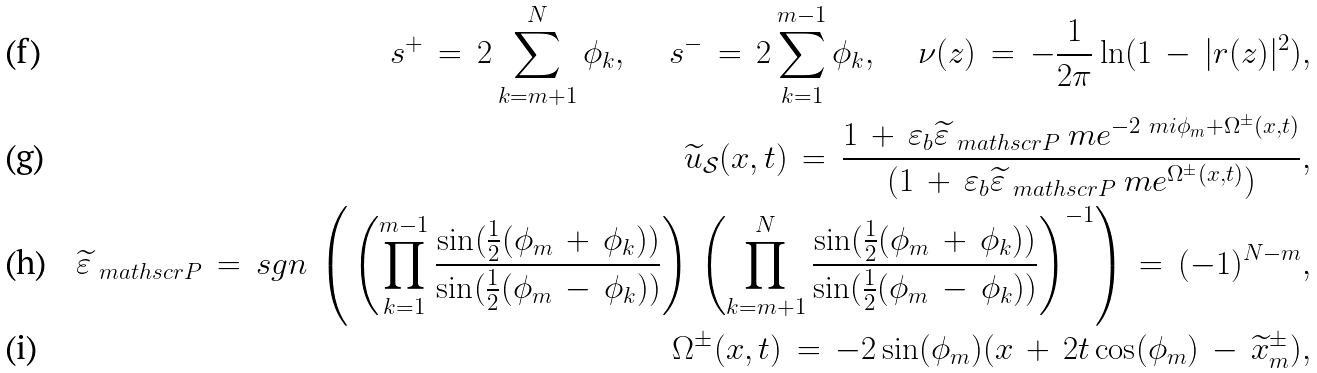<formula> <loc_0><loc_0><loc_500><loc_500>s ^ { + } \, = \, 2 \sum _ { k = m + 1 } ^ { N } \phi _ { k } , \quad \, s ^ { - } \, = \, 2 \sum _ { k = 1 } ^ { m - 1 } \phi _ { k } , \quad \, \nu ( z ) \, = \, - \frac { 1 } { 2 \pi } \ln ( 1 \, - \, | r ( z ) | ^ { 2 } ) , \\ \widetilde { u } _ { \mathcal { S } } ( x , t ) \, = \, \frac { 1 \, + \, \varepsilon _ { b } \widetilde { \varepsilon } _ { \ m a t h s c r { P } } \ m e ^ { - 2 \ m i \phi _ { m } + \Omega ^ { \pm } ( x , t ) } } { ( 1 \, + \, \varepsilon _ { b } \widetilde { \varepsilon } _ { \ m a t h s c r { P } } \ m e ^ { \Omega ^ { \pm } ( x , t ) } ) } , \\ \widetilde { \varepsilon } _ { \ m a t h s c r { P } } \, = \, s g n \, \left ( \, \left ( \prod _ { k = 1 } ^ { m - 1 } \frac { \sin ( \frac { 1 } { 2 } ( \phi _ { m } \, + \, \phi _ { k } ) ) } { \sin ( \frac { 1 } { 2 } ( \phi _ { m } \, - \, \phi _ { k } ) ) } \right ) \, \left ( \prod _ { k = m + 1 } ^ { N } \frac { \sin ( \frac { 1 } { 2 } ( \phi _ { m } \, + \, \phi _ { k } ) ) } { \sin ( \frac { 1 } { 2 } ( \phi _ { m } \, - \, \phi _ { k } ) ) } \right ) ^ { - 1 } \right ) \, = \, ( - 1 ) ^ { N - m } , \\ \Omega ^ { \pm } ( x , t ) \, = \, - 2 \sin ( \phi _ { m } ) ( x \, + \, 2 t \cos ( \phi _ { m } ) \, - \, \widetilde { x } ^ { \pm } _ { m } ) ,</formula> 